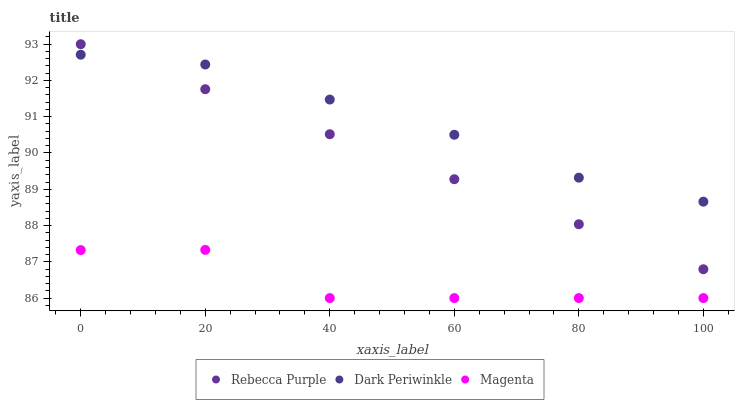Does Magenta have the minimum area under the curve?
Answer yes or no. Yes. Does Dark Periwinkle have the maximum area under the curve?
Answer yes or no. Yes. Does Rebecca Purple have the minimum area under the curve?
Answer yes or no. No. Does Rebecca Purple have the maximum area under the curve?
Answer yes or no. No. Is Rebecca Purple the smoothest?
Answer yes or no. Yes. Is Magenta the roughest?
Answer yes or no. Yes. Is Dark Periwinkle the smoothest?
Answer yes or no. No. Is Dark Periwinkle the roughest?
Answer yes or no. No. Does Magenta have the lowest value?
Answer yes or no. Yes. Does Rebecca Purple have the lowest value?
Answer yes or no. No. Does Rebecca Purple have the highest value?
Answer yes or no. Yes. Does Dark Periwinkle have the highest value?
Answer yes or no. No. Is Magenta less than Dark Periwinkle?
Answer yes or no. Yes. Is Dark Periwinkle greater than Magenta?
Answer yes or no. Yes. Does Dark Periwinkle intersect Rebecca Purple?
Answer yes or no. Yes. Is Dark Periwinkle less than Rebecca Purple?
Answer yes or no. No. Is Dark Periwinkle greater than Rebecca Purple?
Answer yes or no. No. Does Magenta intersect Dark Periwinkle?
Answer yes or no. No. 